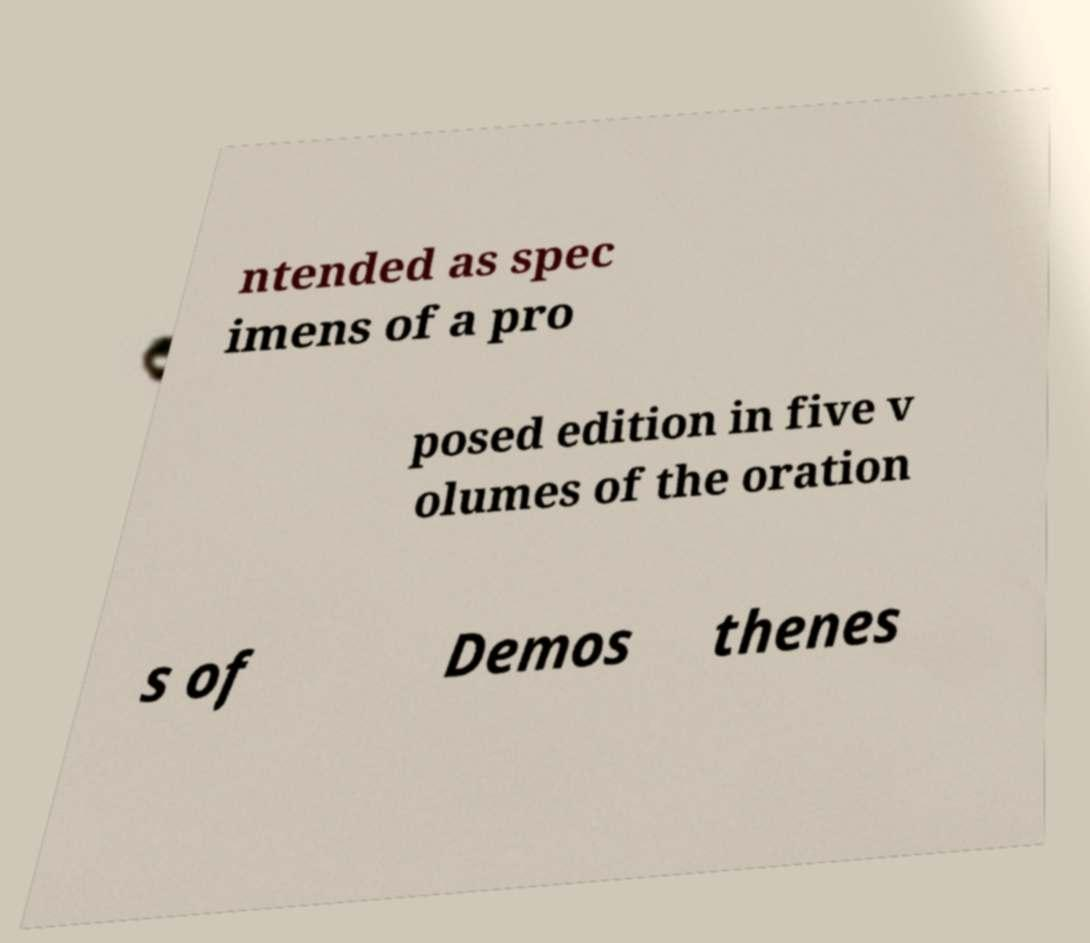Could you extract and type out the text from this image? ntended as spec imens of a pro posed edition in five v olumes of the oration s of Demos thenes 